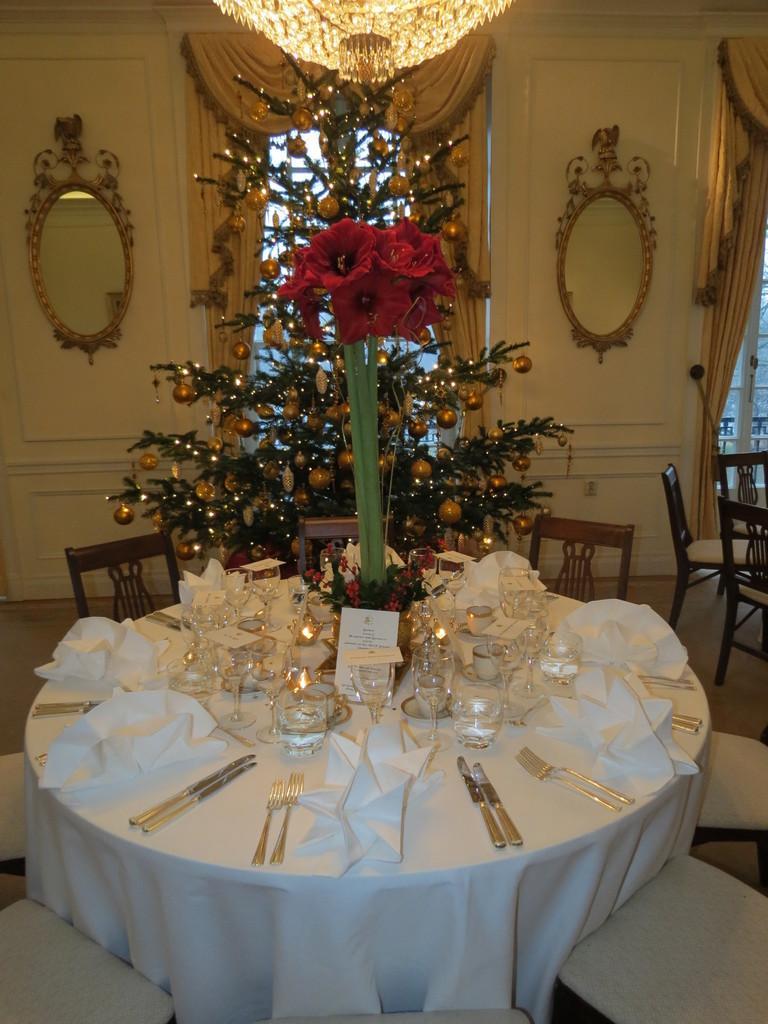Please provide a concise description of this image. Here we can see a table full of spoons,butter knives, forks and glasses present on it and in the middle we can see a Christmas tree decorated and there is a chandelier at the top and we can see Mirrors on the both side on the doors and there are chairs present 